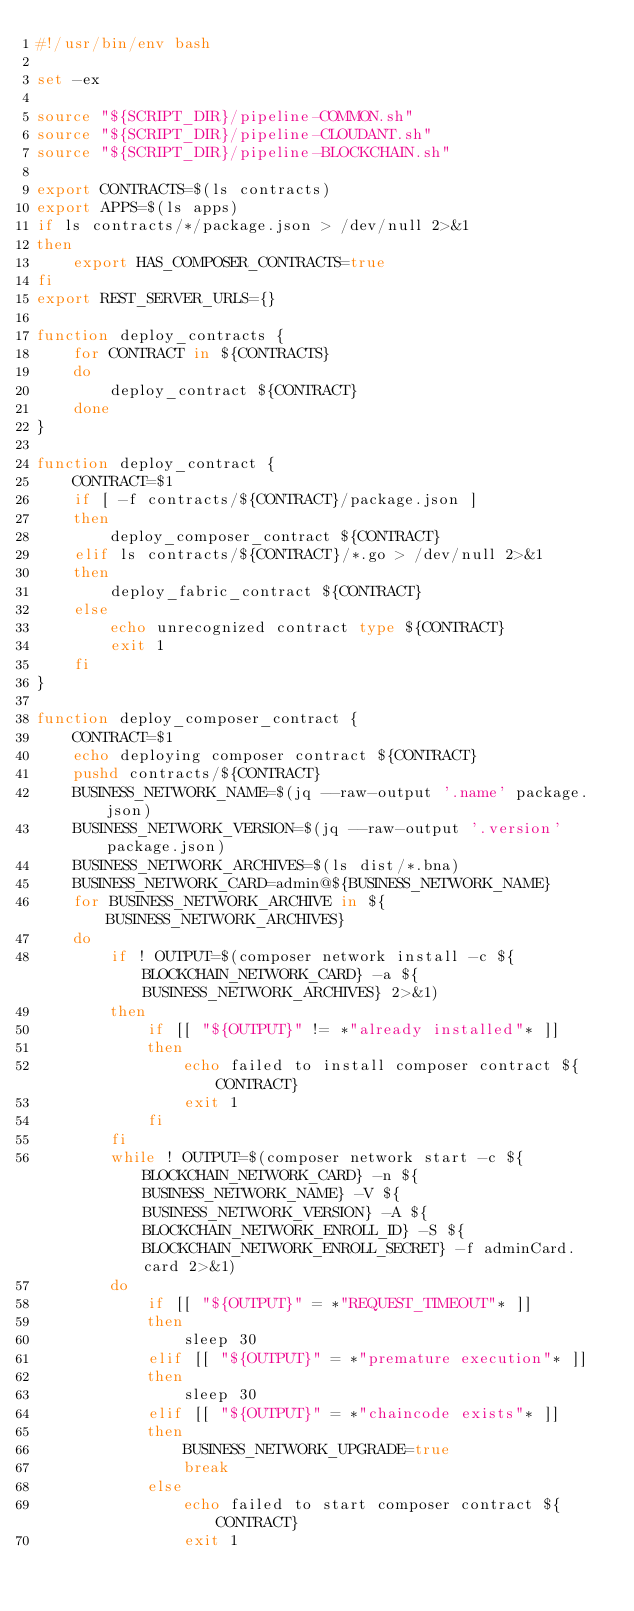<code> <loc_0><loc_0><loc_500><loc_500><_Bash_>#!/usr/bin/env bash

set -ex

source "${SCRIPT_DIR}/pipeline-COMMON.sh"
source "${SCRIPT_DIR}/pipeline-CLOUDANT.sh"
source "${SCRIPT_DIR}/pipeline-BLOCKCHAIN.sh"

export CONTRACTS=$(ls contracts)
export APPS=$(ls apps)
if ls contracts/*/package.json > /dev/null 2>&1
then
    export HAS_COMPOSER_CONTRACTS=true
fi
export REST_SERVER_URLS={}

function deploy_contracts {
    for CONTRACT in ${CONTRACTS}
    do
        deploy_contract ${CONTRACT}
    done
}

function deploy_contract {
    CONTRACT=$1
    if [ -f contracts/${CONTRACT}/package.json ]
    then
        deploy_composer_contract ${CONTRACT}
    elif ls contracts/${CONTRACT}/*.go > /dev/null 2>&1
    then
        deploy_fabric_contract ${CONTRACT}
    else
        echo unrecognized contract type ${CONTRACT}
        exit 1
    fi
}

function deploy_composer_contract {
    CONTRACT=$1
    echo deploying composer contract ${CONTRACT}
    pushd contracts/${CONTRACT}
    BUSINESS_NETWORK_NAME=$(jq --raw-output '.name' package.json)
    BUSINESS_NETWORK_VERSION=$(jq --raw-output '.version' package.json)
    BUSINESS_NETWORK_ARCHIVES=$(ls dist/*.bna)
    BUSINESS_NETWORK_CARD=admin@${BUSINESS_NETWORK_NAME}
    for BUSINESS_NETWORK_ARCHIVE in ${BUSINESS_NETWORK_ARCHIVES}
    do
        if ! OUTPUT=$(composer network install -c ${BLOCKCHAIN_NETWORK_CARD} -a ${BUSINESS_NETWORK_ARCHIVES} 2>&1)
        then
            if [[ "${OUTPUT}" != *"already installed"* ]]
            then
                echo failed to install composer contract ${CONTRACT}
                exit 1
            fi
        fi
        while ! OUTPUT=$(composer network start -c ${BLOCKCHAIN_NETWORK_CARD} -n ${BUSINESS_NETWORK_NAME} -V ${BUSINESS_NETWORK_VERSION} -A ${BLOCKCHAIN_NETWORK_ENROLL_ID} -S ${BLOCKCHAIN_NETWORK_ENROLL_SECRET} -f adminCard.card 2>&1)
        do
            if [[ "${OUTPUT}" = *"REQUEST_TIMEOUT"* ]]
            then
                sleep 30
            elif [[ "${OUTPUT}" = *"premature execution"* ]]
            then
                sleep 30
            elif [[ "${OUTPUT}" = *"chaincode exists"* ]]
            then
                BUSINESS_NETWORK_UPGRADE=true
                break
            else
                echo failed to start composer contract ${CONTRACT}
                exit 1</code> 